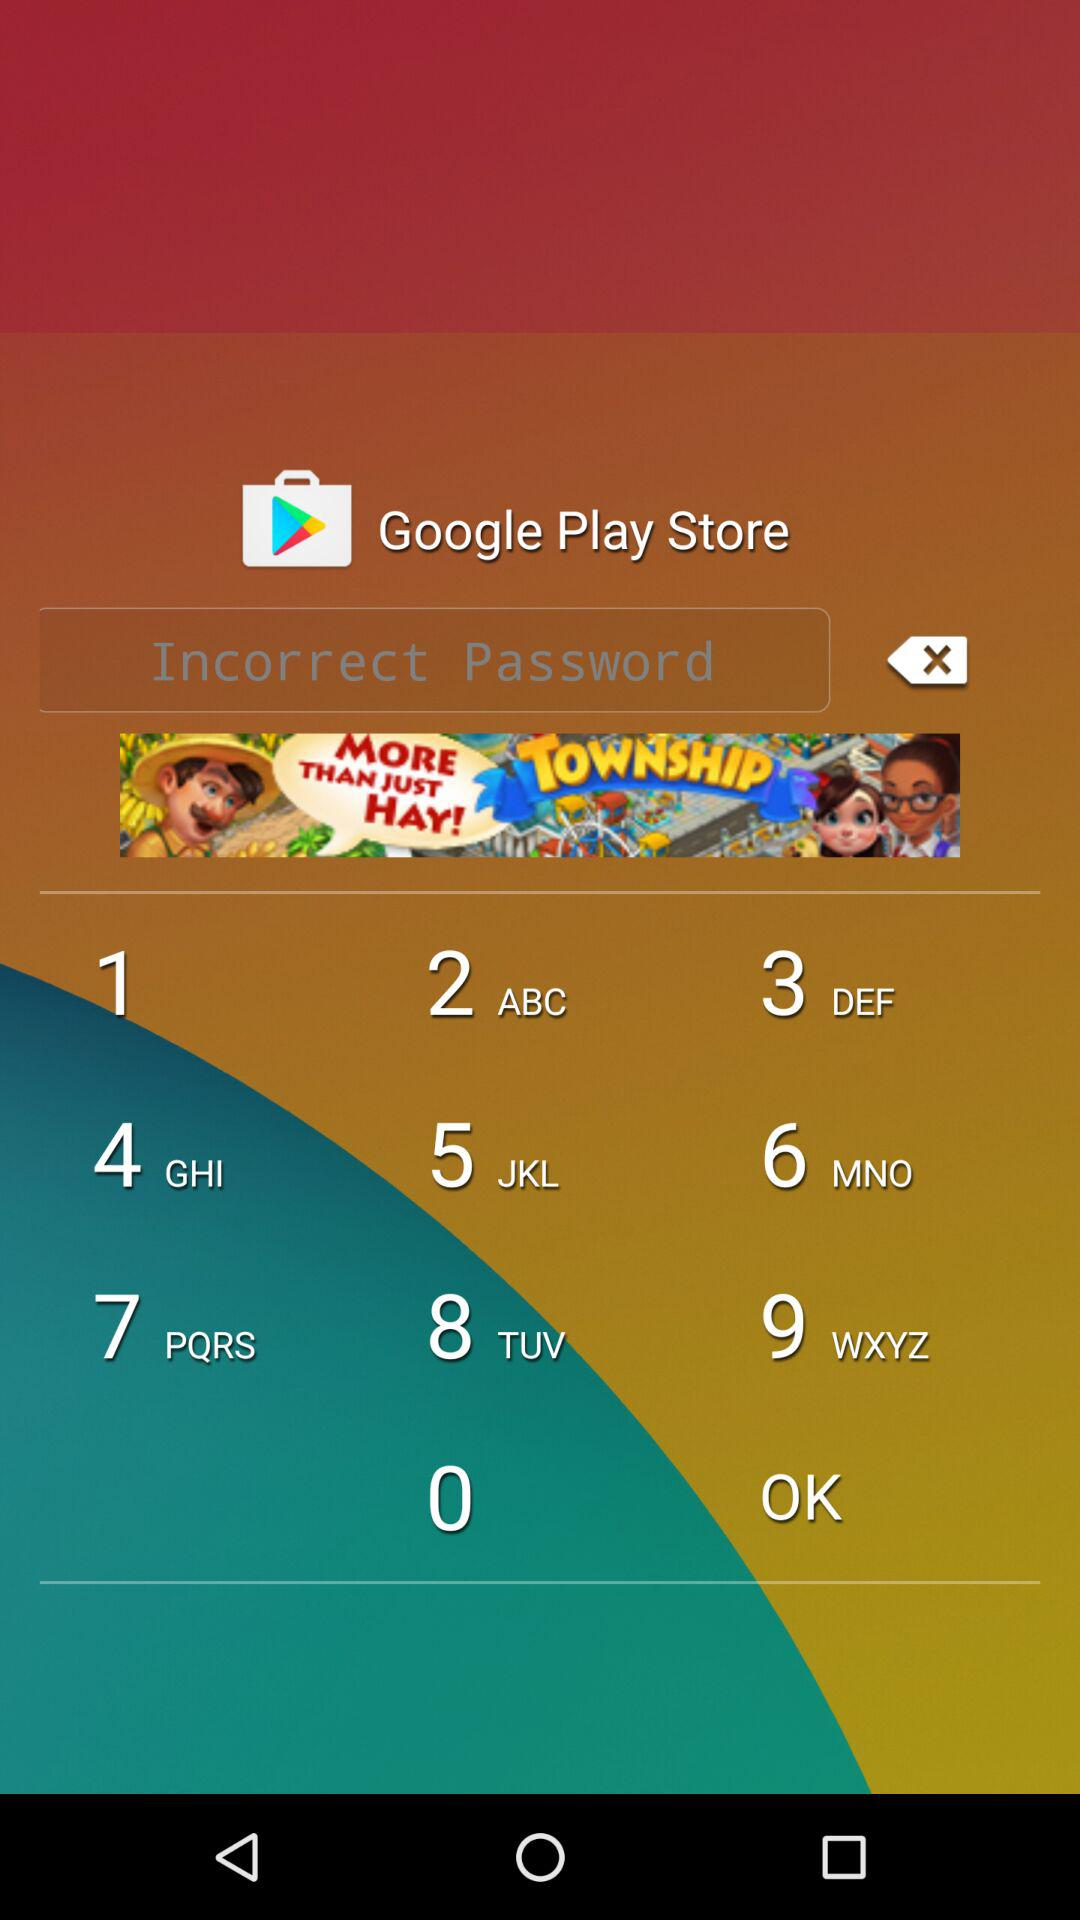What is the application name? The application name is "Uber". 